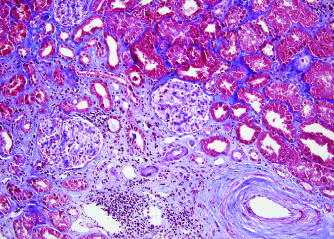do interstitial fibrosis and tubular atrophy result from arteriosclerosis of arteries and arterioles in a chronically rejecting kidney allograft?
Answer the question using a single word or phrase. Yes 